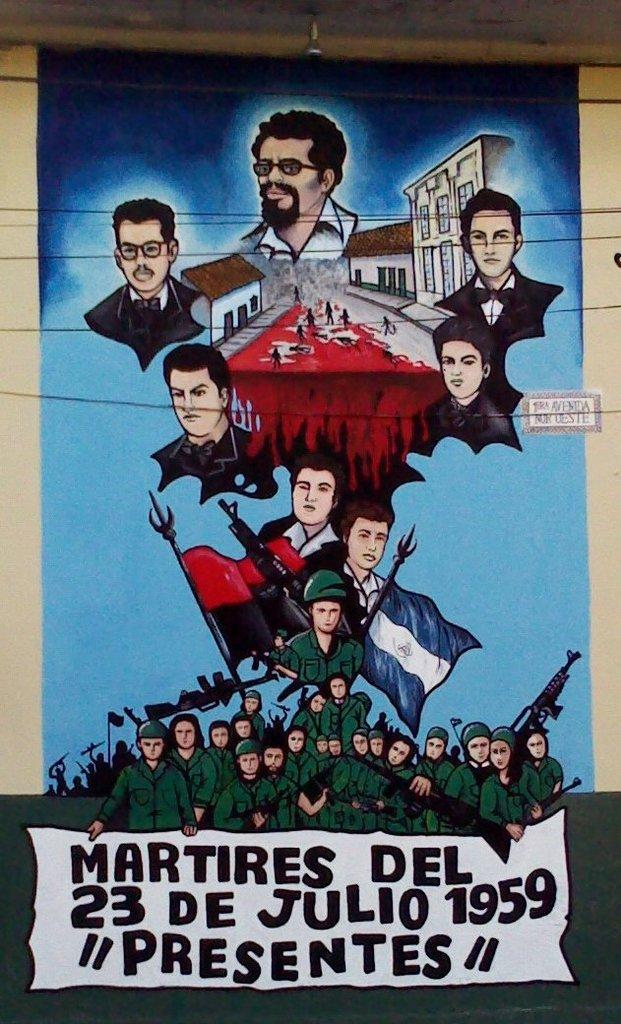<image>
Offer a succinct explanation of the picture presented. A poster showing soldiers presenting the martyrs of 1959 